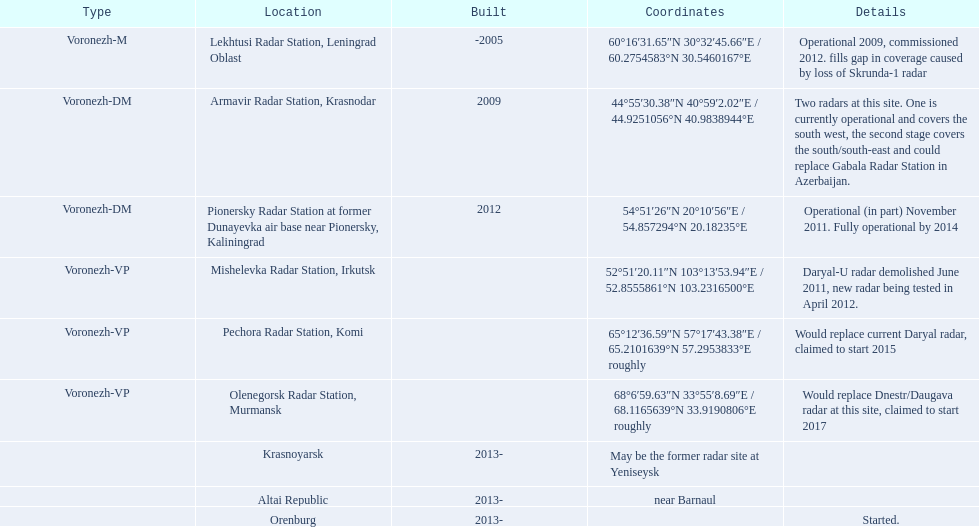What year built is at the top? -2005. 